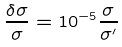<formula> <loc_0><loc_0><loc_500><loc_500>\frac { { \delta } { \sigma } } { \sigma } = 1 0 ^ { - 5 } \frac { \sigma } { { \sigma } ^ { \prime } }</formula> 